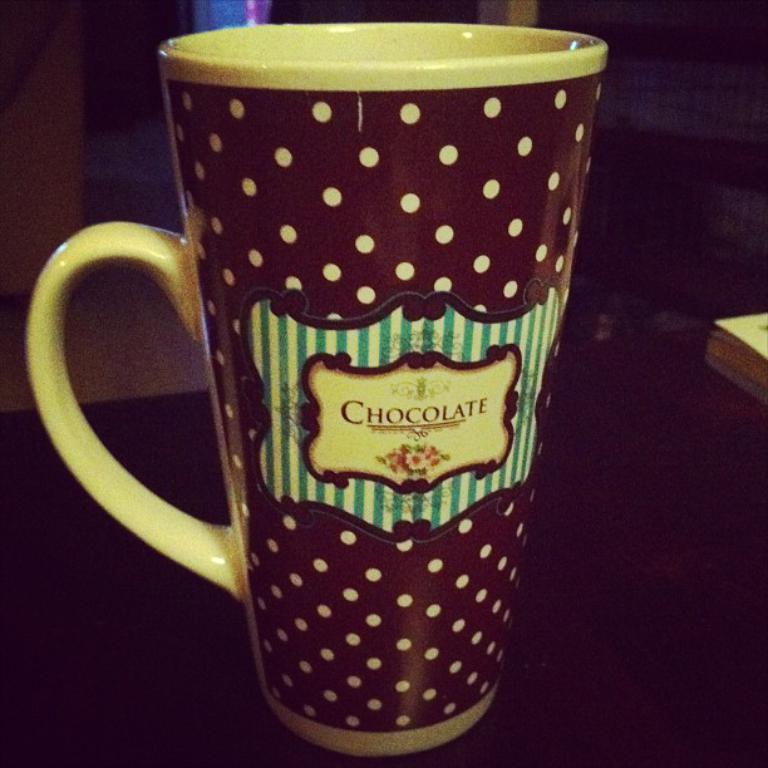What candy is mentioned on the cup?
Ensure brevity in your answer.  Chocolate. 